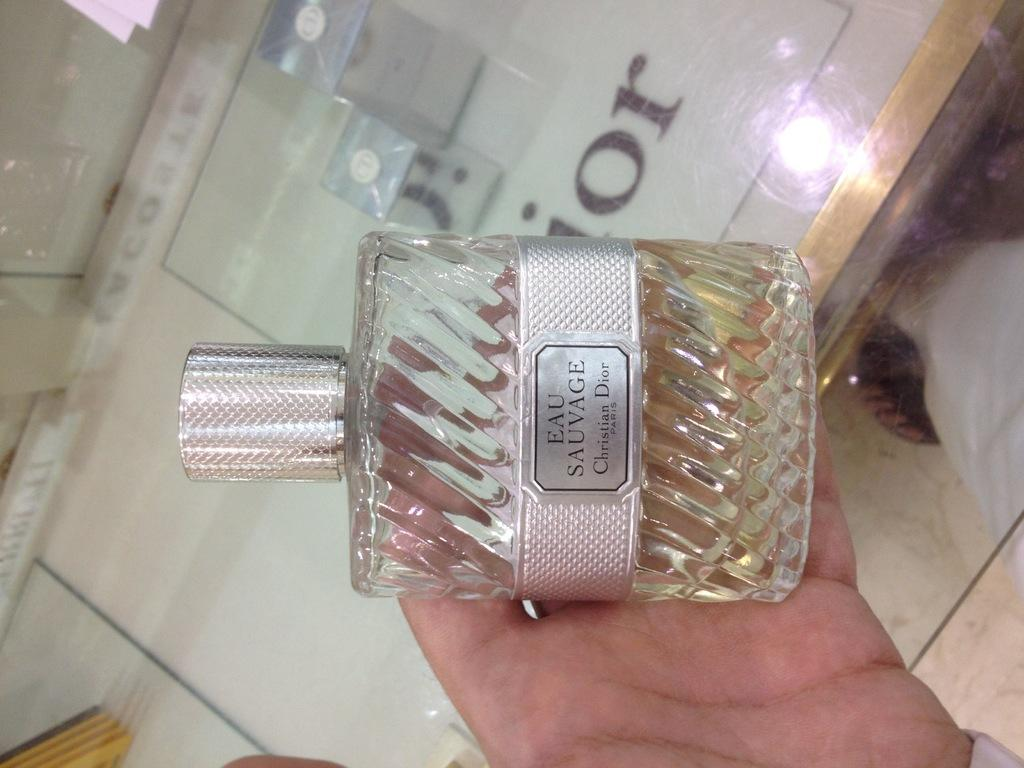<image>
Create a compact narrative representing the image presented. A person holding a glass bottle of Eau Sauvage with silver label and top. 